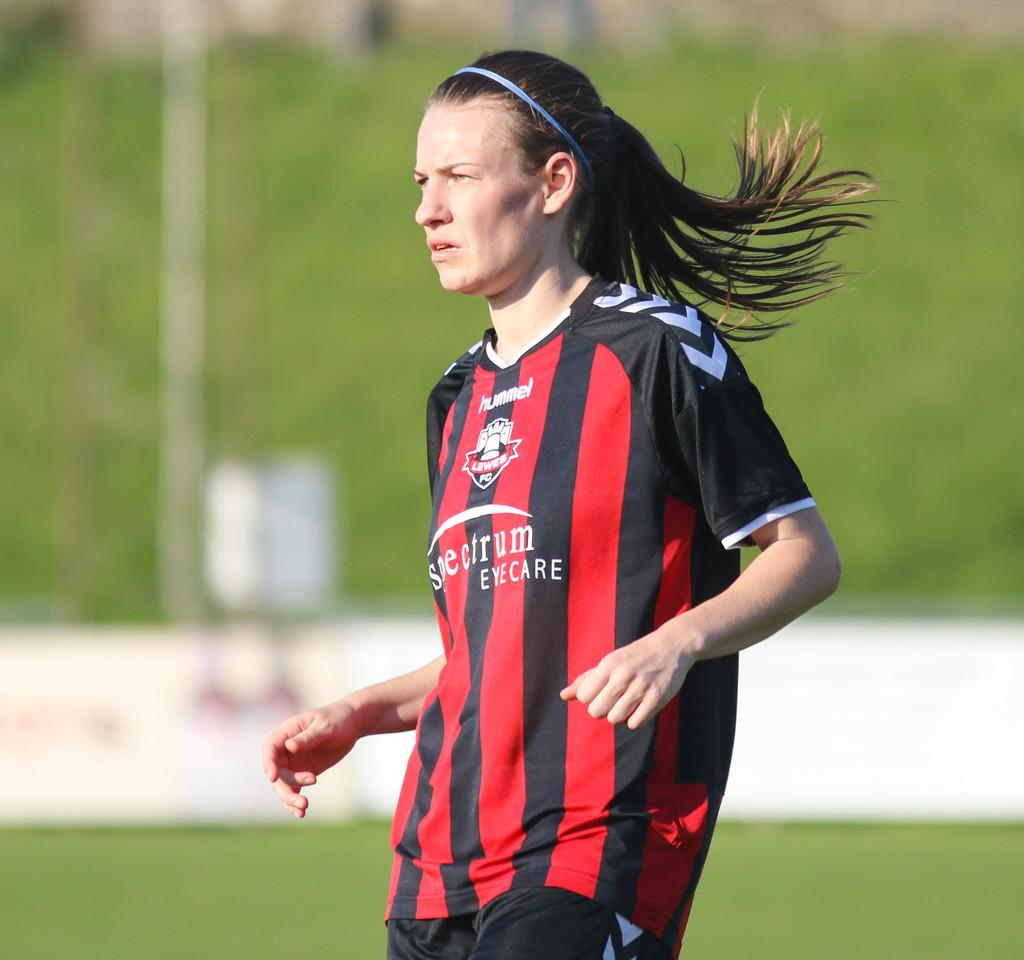<image>
Describe the image concisely. a person in a black and red striped jersey reading EYE CARE 